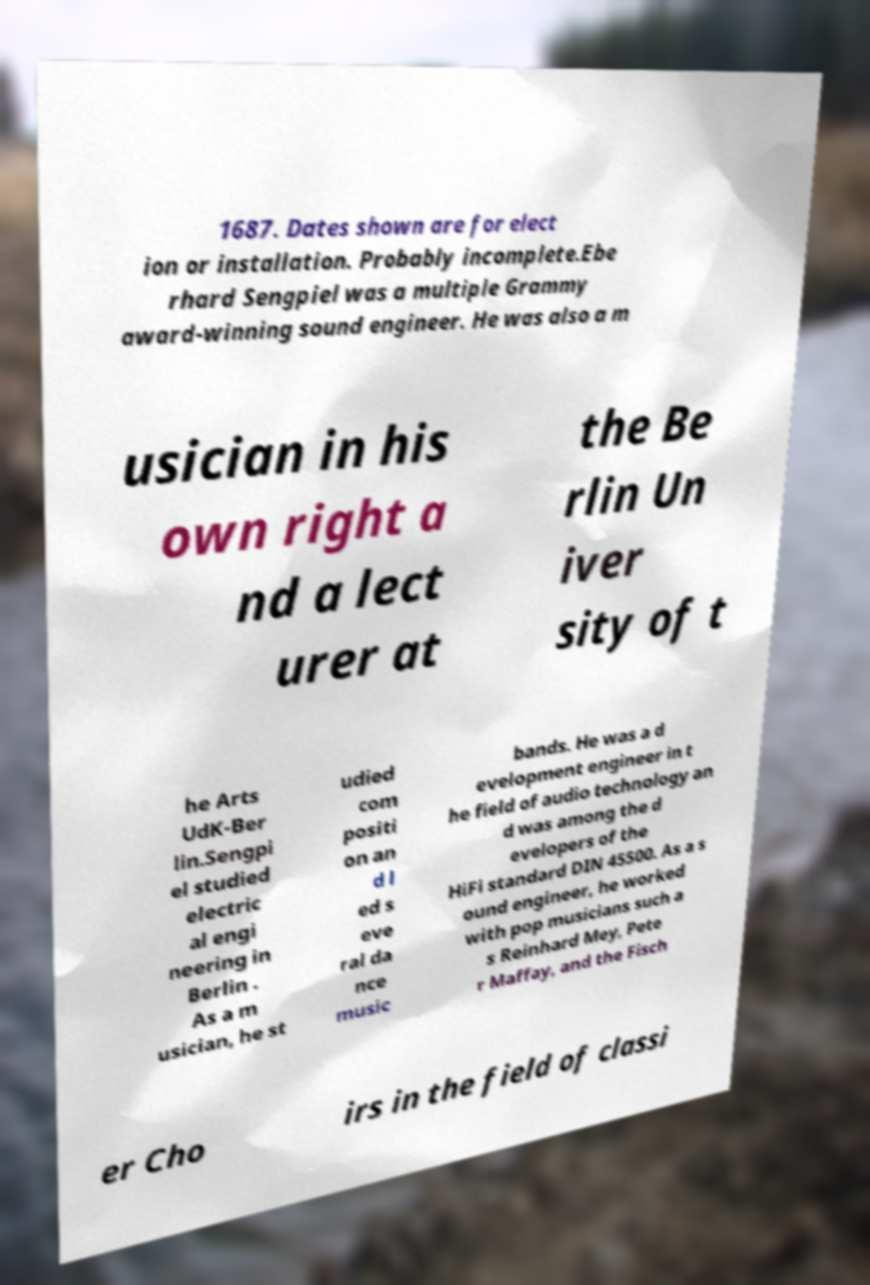Please read and relay the text visible in this image. What does it say? 1687. Dates shown are for elect ion or installation. Probably incomplete.Ebe rhard Sengpiel was a multiple Grammy award-winning sound engineer. He was also a m usician in his own right a nd a lect urer at the Be rlin Un iver sity of t he Arts UdK-Ber lin.Sengpi el studied electric al engi neering in Berlin . As a m usician, he st udied com positi on an d l ed s eve ral da nce music bands. He was a d evelopment engineer in t he field of audio technology an d was among the d evelopers of the HiFi standard DIN 45500. As a s ound engineer, he worked with pop musicians such a s Reinhard Mey, Pete r Maffay, and the Fisch er Cho irs in the field of classi 